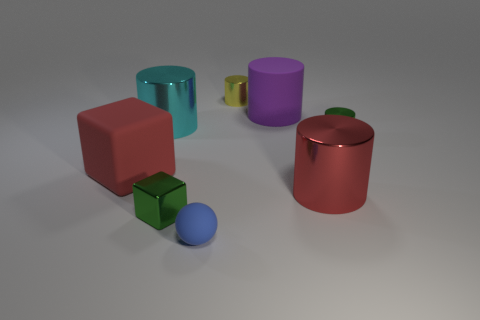Subtract all large red cylinders. How many cylinders are left? 4 Subtract 2 cylinders. How many cylinders are left? 3 Subtract all green cylinders. How many cylinders are left? 4 Subtract all blue cylinders. Subtract all cyan blocks. How many cylinders are left? 5 Add 1 yellow shiny balls. How many objects exist? 9 Subtract all cylinders. How many objects are left? 3 Add 8 metallic blocks. How many metallic blocks are left? 9 Add 1 spheres. How many spheres exist? 2 Subtract 1 red blocks. How many objects are left? 7 Subtract all blue matte things. Subtract all big things. How many objects are left? 3 